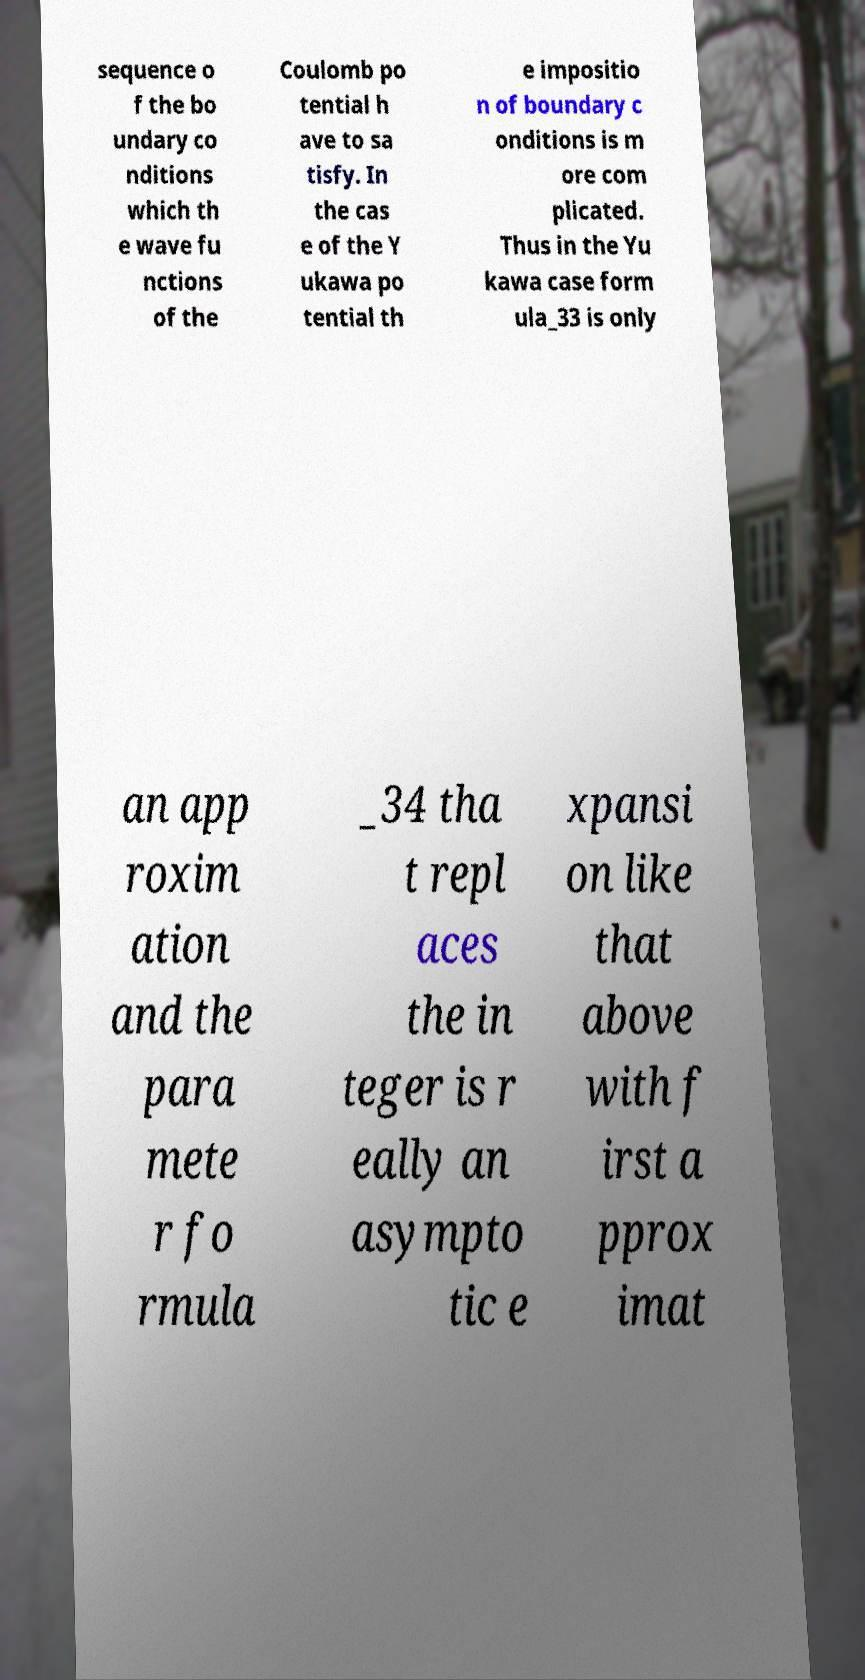Please identify and transcribe the text found in this image. sequence o f the bo undary co nditions which th e wave fu nctions of the Coulomb po tential h ave to sa tisfy. In the cas e of the Y ukawa po tential th e impositio n of boundary c onditions is m ore com plicated. Thus in the Yu kawa case form ula_33 is only an app roxim ation and the para mete r fo rmula _34 tha t repl aces the in teger is r eally an asympto tic e xpansi on like that above with f irst a pprox imat 